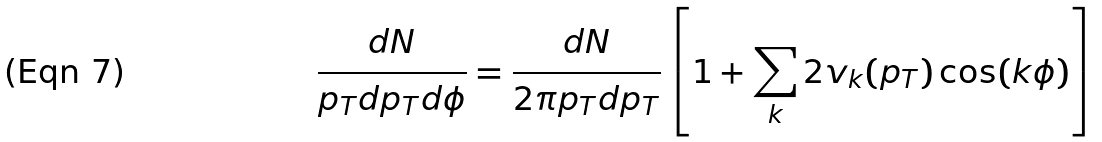<formula> <loc_0><loc_0><loc_500><loc_500>\frac { d N } { p _ { T } d p _ { T } d \phi } = \frac { d N } { 2 \pi p _ { T } d p _ { T } } \left [ 1 + \sum _ { k } 2 v _ { k } ( p _ { T } ) \cos ( k \phi ) \right ]</formula> 